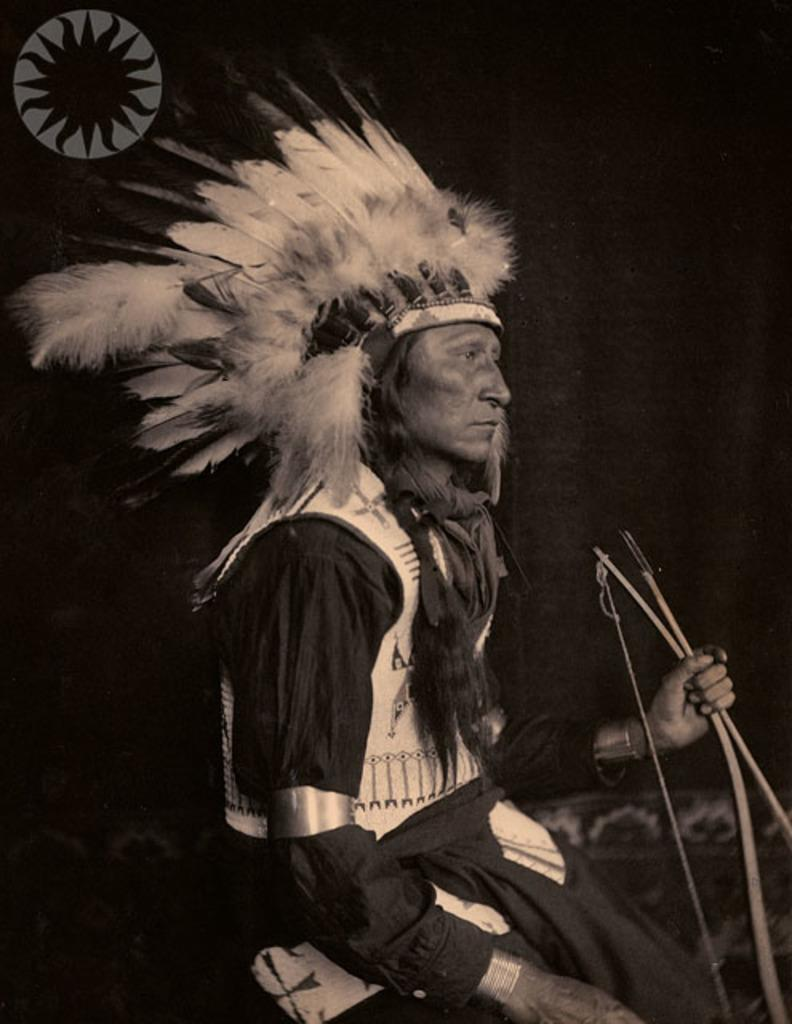Who is present in the image? There is a man in the image. What is the man wearing? The man is wearing a black dress. What object is the man holding? The man is holding a bow. What can be seen in addition to the man and his attire? There are feathers in the image. What is the color of the background in the image? The background of the image is dark. What is the value of the surprise in the image? There is no surprise present in the image, so it is not possible to determine its value. 